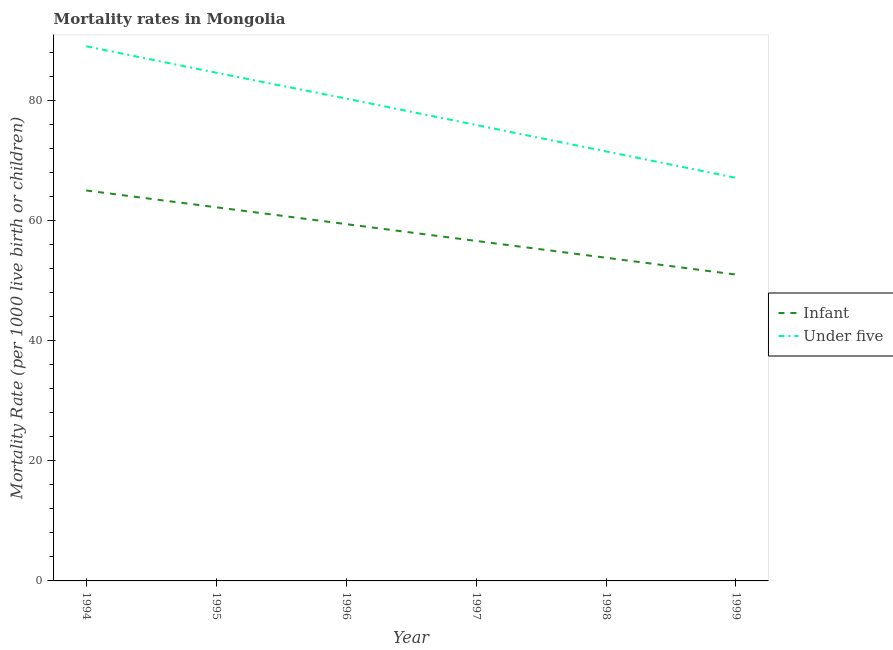Is the number of lines equal to the number of legend labels?
Give a very brief answer. Yes. What is the infant mortality rate in 1999?
Give a very brief answer. 51. Across all years, what is the maximum infant mortality rate?
Offer a terse response. 65. Across all years, what is the minimum under-5 mortality rate?
Offer a terse response. 67.1. In which year was the infant mortality rate minimum?
Provide a succinct answer. 1999. What is the total under-5 mortality rate in the graph?
Offer a very short reply. 468.4. What is the difference between the under-5 mortality rate in 1994 and that in 1995?
Keep it short and to the point. 4.4. What is the difference between the infant mortality rate in 1997 and the under-5 mortality rate in 1996?
Ensure brevity in your answer.  -23.7. What is the average under-5 mortality rate per year?
Ensure brevity in your answer.  78.07. In the year 1997, what is the difference between the infant mortality rate and under-5 mortality rate?
Your answer should be very brief. -19.3. What is the ratio of the under-5 mortality rate in 1994 to that in 1999?
Ensure brevity in your answer.  1.33. What is the difference between the highest and the second highest infant mortality rate?
Provide a short and direct response. 2.8. What is the difference between the highest and the lowest under-5 mortality rate?
Provide a succinct answer. 21.9. Does the infant mortality rate monotonically increase over the years?
Make the answer very short. No. Is the under-5 mortality rate strictly greater than the infant mortality rate over the years?
Provide a succinct answer. Yes. Is the infant mortality rate strictly less than the under-5 mortality rate over the years?
Offer a terse response. Yes. How many years are there in the graph?
Ensure brevity in your answer.  6. Are the values on the major ticks of Y-axis written in scientific E-notation?
Give a very brief answer. No. Does the graph contain grids?
Give a very brief answer. No. How many legend labels are there?
Provide a succinct answer. 2. How are the legend labels stacked?
Keep it short and to the point. Vertical. What is the title of the graph?
Your response must be concise. Mortality rates in Mongolia. Does "Taxes on profits and capital gains" appear as one of the legend labels in the graph?
Your answer should be compact. No. What is the label or title of the Y-axis?
Keep it short and to the point. Mortality Rate (per 1000 live birth or children). What is the Mortality Rate (per 1000 live birth or children) of Under five in 1994?
Provide a succinct answer. 89. What is the Mortality Rate (per 1000 live birth or children) of Infant in 1995?
Your answer should be very brief. 62.2. What is the Mortality Rate (per 1000 live birth or children) of Under five in 1995?
Make the answer very short. 84.6. What is the Mortality Rate (per 1000 live birth or children) in Infant in 1996?
Ensure brevity in your answer.  59.4. What is the Mortality Rate (per 1000 live birth or children) of Under five in 1996?
Keep it short and to the point. 80.3. What is the Mortality Rate (per 1000 live birth or children) in Infant in 1997?
Offer a very short reply. 56.6. What is the Mortality Rate (per 1000 live birth or children) in Under five in 1997?
Ensure brevity in your answer.  75.9. What is the Mortality Rate (per 1000 live birth or children) of Infant in 1998?
Give a very brief answer. 53.8. What is the Mortality Rate (per 1000 live birth or children) in Under five in 1998?
Your response must be concise. 71.5. What is the Mortality Rate (per 1000 live birth or children) in Under five in 1999?
Ensure brevity in your answer.  67.1. Across all years, what is the maximum Mortality Rate (per 1000 live birth or children) of Infant?
Provide a short and direct response. 65. Across all years, what is the maximum Mortality Rate (per 1000 live birth or children) of Under five?
Provide a short and direct response. 89. Across all years, what is the minimum Mortality Rate (per 1000 live birth or children) in Under five?
Provide a short and direct response. 67.1. What is the total Mortality Rate (per 1000 live birth or children) in Infant in the graph?
Your answer should be compact. 348. What is the total Mortality Rate (per 1000 live birth or children) in Under five in the graph?
Make the answer very short. 468.4. What is the difference between the Mortality Rate (per 1000 live birth or children) in Under five in 1994 and that in 1996?
Your answer should be compact. 8.7. What is the difference between the Mortality Rate (per 1000 live birth or children) in Under five in 1994 and that in 1997?
Offer a terse response. 13.1. What is the difference between the Mortality Rate (per 1000 live birth or children) of Infant in 1994 and that in 1998?
Your answer should be compact. 11.2. What is the difference between the Mortality Rate (per 1000 live birth or children) in Under five in 1994 and that in 1999?
Ensure brevity in your answer.  21.9. What is the difference between the Mortality Rate (per 1000 live birth or children) of Under five in 1995 and that in 1996?
Offer a very short reply. 4.3. What is the difference between the Mortality Rate (per 1000 live birth or children) of Under five in 1995 and that in 1998?
Your answer should be compact. 13.1. What is the difference between the Mortality Rate (per 1000 live birth or children) of Under five in 1995 and that in 1999?
Keep it short and to the point. 17.5. What is the difference between the Mortality Rate (per 1000 live birth or children) of Infant in 1996 and that in 1997?
Provide a succinct answer. 2.8. What is the difference between the Mortality Rate (per 1000 live birth or children) in Under five in 1996 and that in 1997?
Make the answer very short. 4.4. What is the difference between the Mortality Rate (per 1000 live birth or children) of Infant in 1996 and that in 1998?
Ensure brevity in your answer.  5.6. What is the difference between the Mortality Rate (per 1000 live birth or children) in Under five in 1996 and that in 1998?
Ensure brevity in your answer.  8.8. What is the difference between the Mortality Rate (per 1000 live birth or children) in Infant in 1996 and that in 1999?
Make the answer very short. 8.4. What is the difference between the Mortality Rate (per 1000 live birth or children) of Under five in 1997 and that in 1998?
Give a very brief answer. 4.4. What is the difference between the Mortality Rate (per 1000 live birth or children) in Infant in 1997 and that in 1999?
Make the answer very short. 5.6. What is the difference between the Mortality Rate (per 1000 live birth or children) of Under five in 1997 and that in 1999?
Make the answer very short. 8.8. What is the difference between the Mortality Rate (per 1000 live birth or children) in Under five in 1998 and that in 1999?
Ensure brevity in your answer.  4.4. What is the difference between the Mortality Rate (per 1000 live birth or children) of Infant in 1994 and the Mortality Rate (per 1000 live birth or children) of Under five in 1995?
Provide a short and direct response. -19.6. What is the difference between the Mortality Rate (per 1000 live birth or children) of Infant in 1994 and the Mortality Rate (per 1000 live birth or children) of Under five in 1996?
Your answer should be compact. -15.3. What is the difference between the Mortality Rate (per 1000 live birth or children) in Infant in 1994 and the Mortality Rate (per 1000 live birth or children) in Under five in 1997?
Keep it short and to the point. -10.9. What is the difference between the Mortality Rate (per 1000 live birth or children) in Infant in 1994 and the Mortality Rate (per 1000 live birth or children) in Under five in 1999?
Ensure brevity in your answer.  -2.1. What is the difference between the Mortality Rate (per 1000 live birth or children) in Infant in 1995 and the Mortality Rate (per 1000 live birth or children) in Under five in 1996?
Your response must be concise. -18.1. What is the difference between the Mortality Rate (per 1000 live birth or children) in Infant in 1995 and the Mortality Rate (per 1000 live birth or children) in Under five in 1997?
Make the answer very short. -13.7. What is the difference between the Mortality Rate (per 1000 live birth or children) in Infant in 1995 and the Mortality Rate (per 1000 live birth or children) in Under five in 1999?
Your answer should be very brief. -4.9. What is the difference between the Mortality Rate (per 1000 live birth or children) of Infant in 1996 and the Mortality Rate (per 1000 live birth or children) of Under five in 1997?
Your answer should be compact. -16.5. What is the difference between the Mortality Rate (per 1000 live birth or children) in Infant in 1997 and the Mortality Rate (per 1000 live birth or children) in Under five in 1998?
Ensure brevity in your answer.  -14.9. What is the difference between the Mortality Rate (per 1000 live birth or children) of Infant in 1997 and the Mortality Rate (per 1000 live birth or children) of Under five in 1999?
Provide a succinct answer. -10.5. What is the average Mortality Rate (per 1000 live birth or children) of Under five per year?
Ensure brevity in your answer.  78.07. In the year 1994, what is the difference between the Mortality Rate (per 1000 live birth or children) in Infant and Mortality Rate (per 1000 live birth or children) in Under five?
Keep it short and to the point. -24. In the year 1995, what is the difference between the Mortality Rate (per 1000 live birth or children) of Infant and Mortality Rate (per 1000 live birth or children) of Under five?
Offer a terse response. -22.4. In the year 1996, what is the difference between the Mortality Rate (per 1000 live birth or children) of Infant and Mortality Rate (per 1000 live birth or children) of Under five?
Your answer should be very brief. -20.9. In the year 1997, what is the difference between the Mortality Rate (per 1000 live birth or children) in Infant and Mortality Rate (per 1000 live birth or children) in Under five?
Your answer should be very brief. -19.3. In the year 1998, what is the difference between the Mortality Rate (per 1000 live birth or children) of Infant and Mortality Rate (per 1000 live birth or children) of Under five?
Keep it short and to the point. -17.7. In the year 1999, what is the difference between the Mortality Rate (per 1000 live birth or children) of Infant and Mortality Rate (per 1000 live birth or children) of Under five?
Give a very brief answer. -16.1. What is the ratio of the Mortality Rate (per 1000 live birth or children) in Infant in 1994 to that in 1995?
Your answer should be very brief. 1.04. What is the ratio of the Mortality Rate (per 1000 live birth or children) in Under five in 1994 to that in 1995?
Make the answer very short. 1.05. What is the ratio of the Mortality Rate (per 1000 live birth or children) of Infant in 1994 to that in 1996?
Make the answer very short. 1.09. What is the ratio of the Mortality Rate (per 1000 live birth or children) of Under five in 1994 to that in 1996?
Keep it short and to the point. 1.11. What is the ratio of the Mortality Rate (per 1000 live birth or children) in Infant in 1994 to that in 1997?
Provide a short and direct response. 1.15. What is the ratio of the Mortality Rate (per 1000 live birth or children) in Under five in 1994 to that in 1997?
Your answer should be compact. 1.17. What is the ratio of the Mortality Rate (per 1000 live birth or children) in Infant in 1994 to that in 1998?
Give a very brief answer. 1.21. What is the ratio of the Mortality Rate (per 1000 live birth or children) in Under five in 1994 to that in 1998?
Your answer should be compact. 1.24. What is the ratio of the Mortality Rate (per 1000 live birth or children) in Infant in 1994 to that in 1999?
Your answer should be very brief. 1.27. What is the ratio of the Mortality Rate (per 1000 live birth or children) in Under five in 1994 to that in 1999?
Provide a succinct answer. 1.33. What is the ratio of the Mortality Rate (per 1000 live birth or children) in Infant in 1995 to that in 1996?
Your response must be concise. 1.05. What is the ratio of the Mortality Rate (per 1000 live birth or children) in Under five in 1995 to that in 1996?
Ensure brevity in your answer.  1.05. What is the ratio of the Mortality Rate (per 1000 live birth or children) of Infant in 1995 to that in 1997?
Offer a terse response. 1.1. What is the ratio of the Mortality Rate (per 1000 live birth or children) in Under five in 1995 to that in 1997?
Give a very brief answer. 1.11. What is the ratio of the Mortality Rate (per 1000 live birth or children) in Infant in 1995 to that in 1998?
Provide a short and direct response. 1.16. What is the ratio of the Mortality Rate (per 1000 live birth or children) in Under five in 1995 to that in 1998?
Provide a succinct answer. 1.18. What is the ratio of the Mortality Rate (per 1000 live birth or children) in Infant in 1995 to that in 1999?
Provide a succinct answer. 1.22. What is the ratio of the Mortality Rate (per 1000 live birth or children) of Under five in 1995 to that in 1999?
Offer a very short reply. 1.26. What is the ratio of the Mortality Rate (per 1000 live birth or children) in Infant in 1996 to that in 1997?
Give a very brief answer. 1.05. What is the ratio of the Mortality Rate (per 1000 live birth or children) of Under five in 1996 to that in 1997?
Your answer should be very brief. 1.06. What is the ratio of the Mortality Rate (per 1000 live birth or children) in Infant in 1996 to that in 1998?
Offer a terse response. 1.1. What is the ratio of the Mortality Rate (per 1000 live birth or children) of Under five in 1996 to that in 1998?
Ensure brevity in your answer.  1.12. What is the ratio of the Mortality Rate (per 1000 live birth or children) of Infant in 1996 to that in 1999?
Offer a terse response. 1.16. What is the ratio of the Mortality Rate (per 1000 live birth or children) in Under five in 1996 to that in 1999?
Your answer should be compact. 1.2. What is the ratio of the Mortality Rate (per 1000 live birth or children) in Infant in 1997 to that in 1998?
Give a very brief answer. 1.05. What is the ratio of the Mortality Rate (per 1000 live birth or children) of Under five in 1997 to that in 1998?
Your response must be concise. 1.06. What is the ratio of the Mortality Rate (per 1000 live birth or children) in Infant in 1997 to that in 1999?
Your response must be concise. 1.11. What is the ratio of the Mortality Rate (per 1000 live birth or children) of Under five in 1997 to that in 1999?
Keep it short and to the point. 1.13. What is the ratio of the Mortality Rate (per 1000 live birth or children) in Infant in 1998 to that in 1999?
Provide a succinct answer. 1.05. What is the ratio of the Mortality Rate (per 1000 live birth or children) of Under five in 1998 to that in 1999?
Give a very brief answer. 1.07. What is the difference between the highest and the second highest Mortality Rate (per 1000 live birth or children) of Infant?
Ensure brevity in your answer.  2.8. What is the difference between the highest and the lowest Mortality Rate (per 1000 live birth or children) of Infant?
Give a very brief answer. 14. What is the difference between the highest and the lowest Mortality Rate (per 1000 live birth or children) of Under five?
Ensure brevity in your answer.  21.9. 